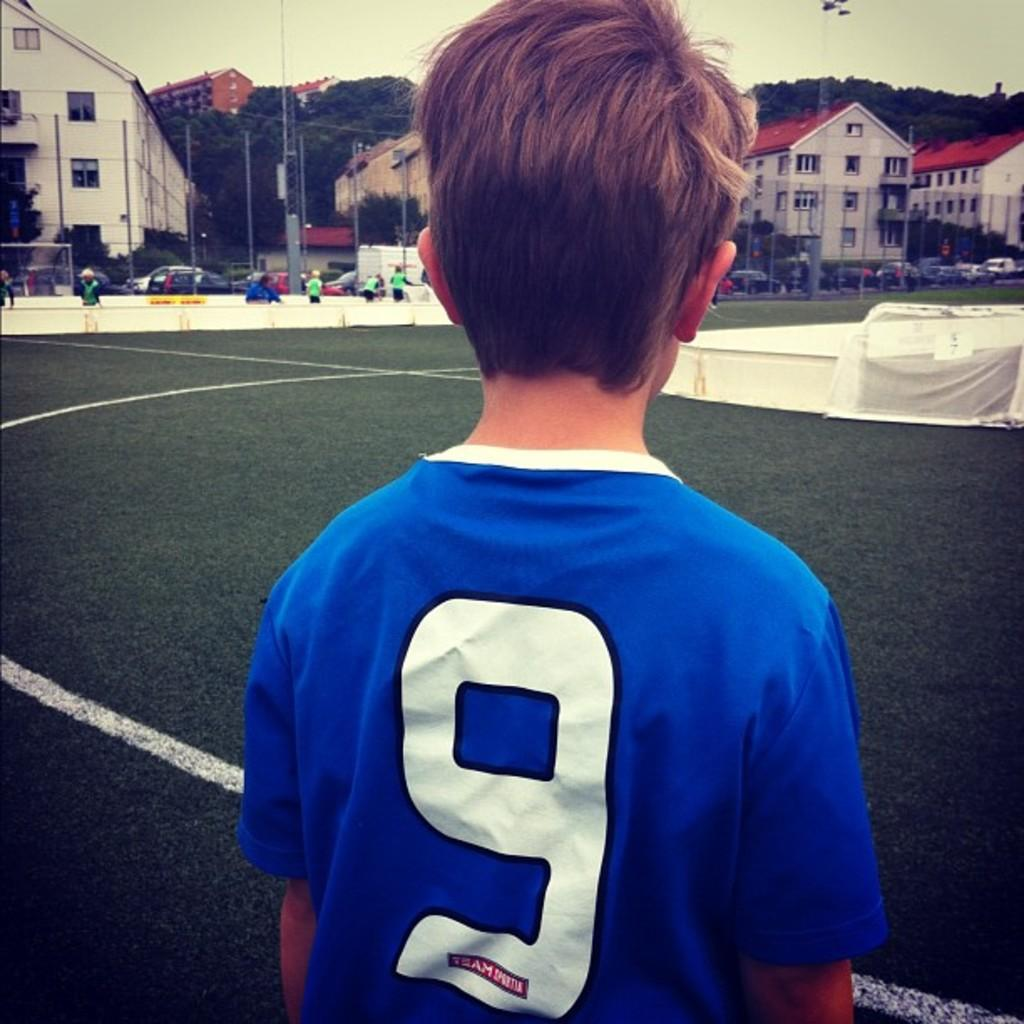<image>
Render a clear and concise summary of the photo. Boy wearing a blue shirt which says the number 9 on it. 